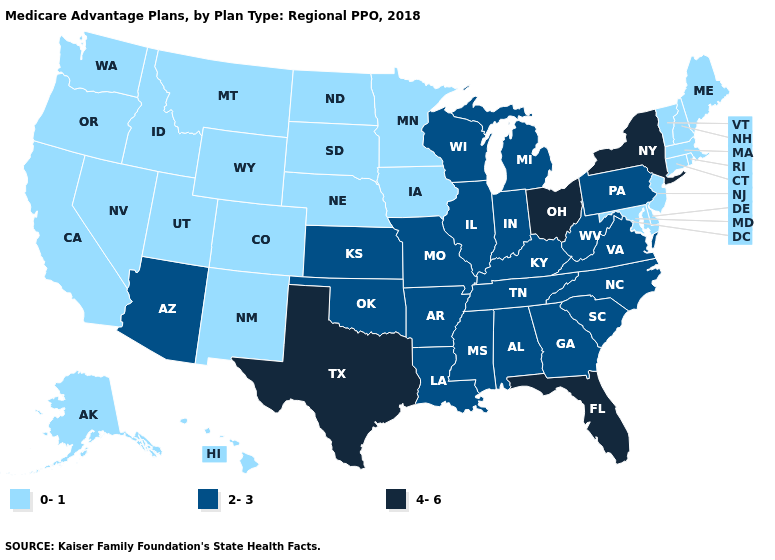Does Delaware have the lowest value in the South?
Concise answer only. Yes. Does California have the same value as New York?
Answer briefly. No. Does Kansas have a lower value than New York?
Quick response, please. Yes. Does the first symbol in the legend represent the smallest category?
Keep it brief. Yes. Name the states that have a value in the range 4-6?
Give a very brief answer. Florida, New York, Ohio, Texas. Which states hav the highest value in the South?
Short answer required. Florida, Texas. Does New Hampshire have the lowest value in the Northeast?
Write a very short answer. Yes. Which states have the highest value in the USA?
Give a very brief answer. Florida, New York, Ohio, Texas. Does Virginia have the same value as South Carolina?
Concise answer only. Yes. Among the states that border Wisconsin , does Iowa have the lowest value?
Answer briefly. Yes. Name the states that have a value in the range 0-1?
Concise answer only. Alaska, California, Colorado, Connecticut, Delaware, Hawaii, Iowa, Idaho, Massachusetts, Maryland, Maine, Minnesota, Montana, North Dakota, Nebraska, New Hampshire, New Jersey, New Mexico, Nevada, Oregon, Rhode Island, South Dakota, Utah, Vermont, Washington, Wyoming. Does Wyoming have the same value as Missouri?
Answer briefly. No. Among the states that border Alabama , which have the lowest value?
Answer briefly. Georgia, Mississippi, Tennessee. Among the states that border Wyoming , which have the highest value?
Keep it brief. Colorado, Idaho, Montana, Nebraska, South Dakota, Utah. Name the states that have a value in the range 0-1?
Give a very brief answer. Alaska, California, Colorado, Connecticut, Delaware, Hawaii, Iowa, Idaho, Massachusetts, Maryland, Maine, Minnesota, Montana, North Dakota, Nebraska, New Hampshire, New Jersey, New Mexico, Nevada, Oregon, Rhode Island, South Dakota, Utah, Vermont, Washington, Wyoming. 